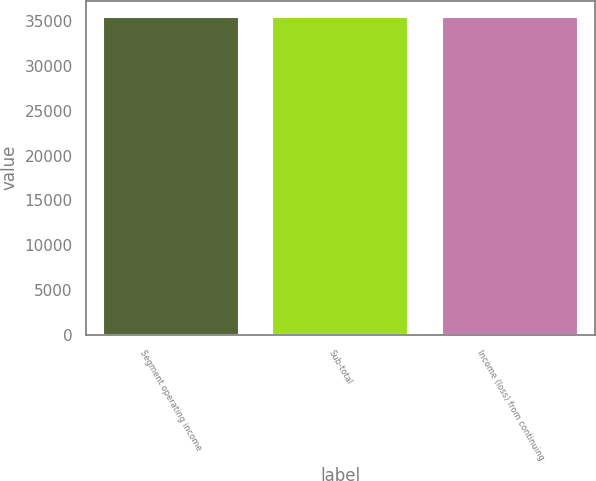Convert chart. <chart><loc_0><loc_0><loc_500><loc_500><bar_chart><fcel>Segment operating income<fcel>Sub-total<fcel>Income (loss) from continuing<nl><fcel>35528<fcel>35528.1<fcel>35528.2<nl></chart> 